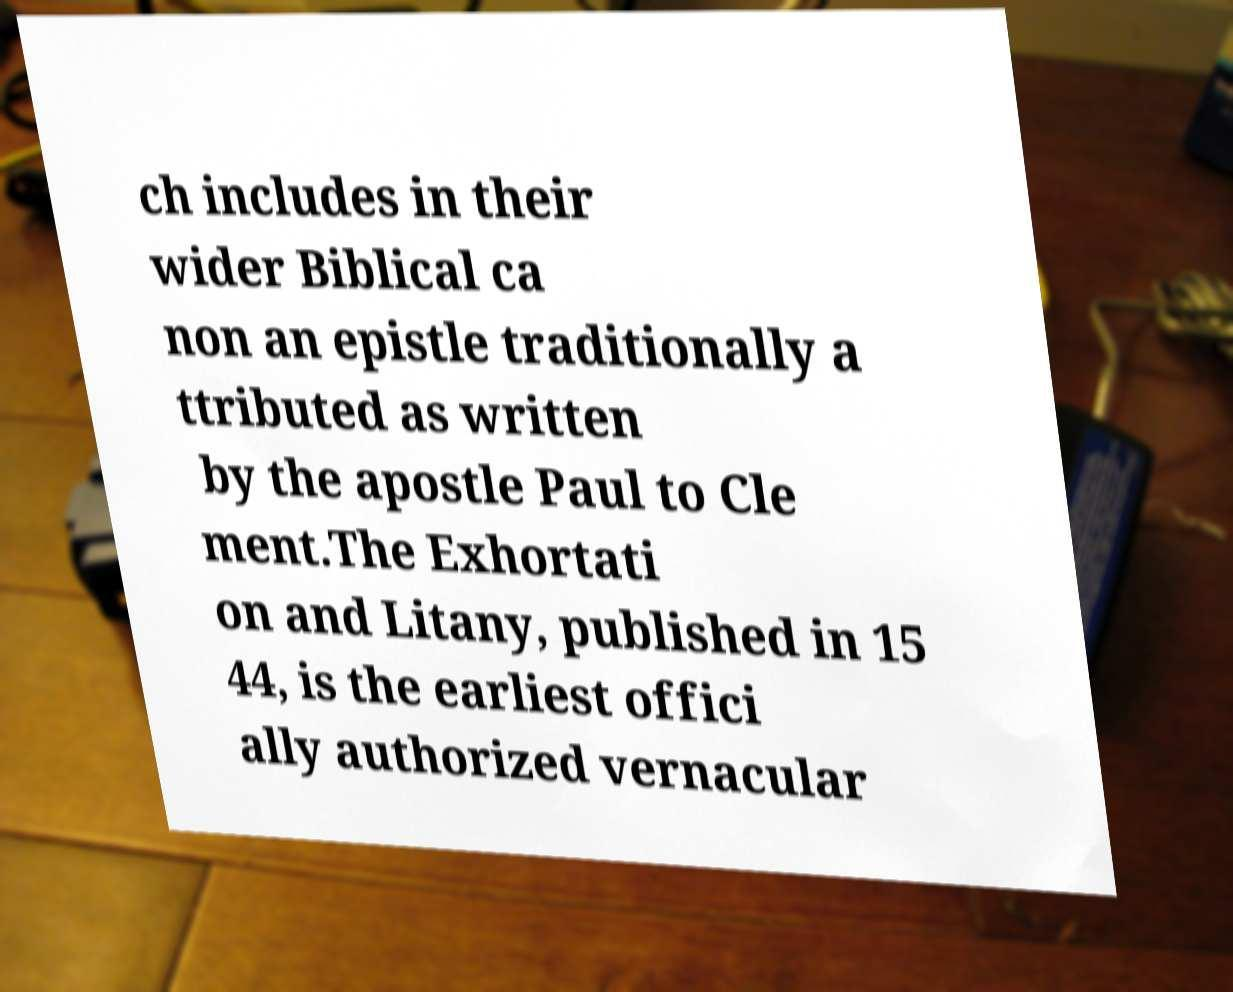What messages or text are displayed in this image? I need them in a readable, typed format. ch includes in their wider Biblical ca non an epistle traditionally a ttributed as written by the apostle Paul to Cle ment.The Exhortati on and Litany, published in 15 44, is the earliest offici ally authorized vernacular 